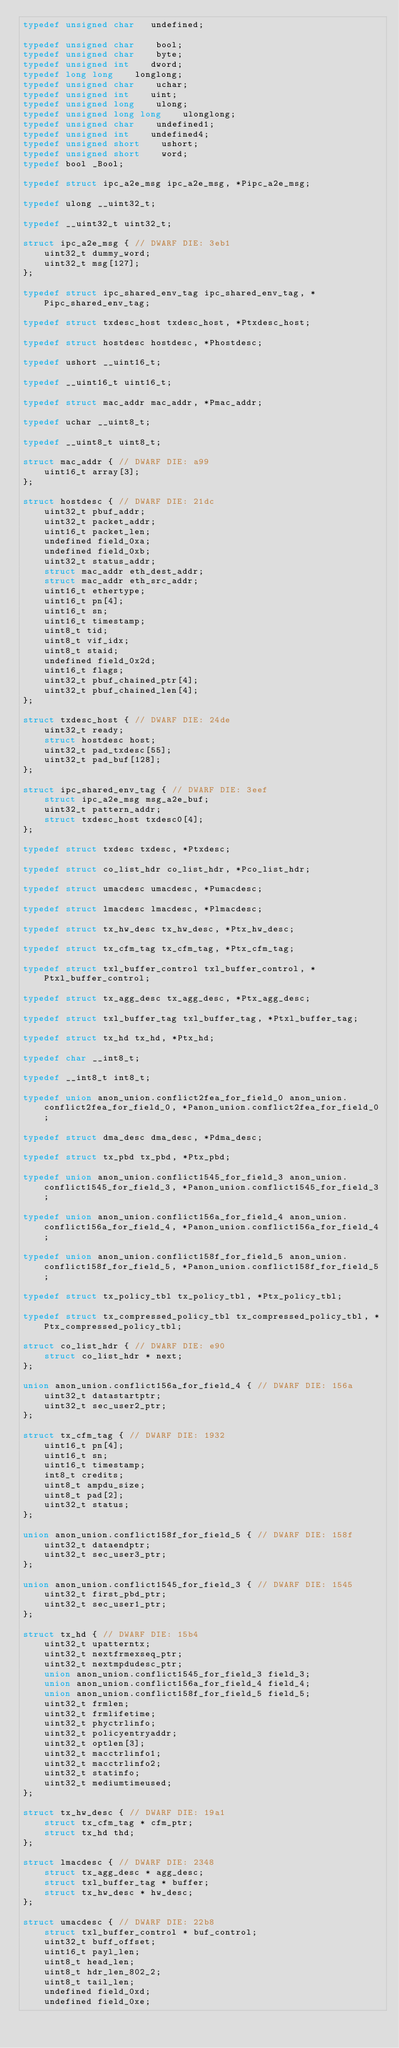Convert code to text. <code><loc_0><loc_0><loc_500><loc_500><_C_>typedef unsigned char   undefined;

typedef unsigned char    bool;
typedef unsigned char    byte;
typedef unsigned int    dword;
typedef long long    longlong;
typedef unsigned char    uchar;
typedef unsigned int    uint;
typedef unsigned long    ulong;
typedef unsigned long long    ulonglong;
typedef unsigned char    undefined1;
typedef unsigned int    undefined4;
typedef unsigned short    ushort;
typedef unsigned short    word;
typedef bool _Bool;

typedef struct ipc_a2e_msg ipc_a2e_msg, *Pipc_a2e_msg;

typedef ulong __uint32_t;

typedef __uint32_t uint32_t;

struct ipc_a2e_msg { // DWARF DIE: 3eb1
    uint32_t dummy_word;
    uint32_t msg[127];
};

typedef struct ipc_shared_env_tag ipc_shared_env_tag, *Pipc_shared_env_tag;

typedef struct txdesc_host txdesc_host, *Ptxdesc_host;

typedef struct hostdesc hostdesc, *Phostdesc;

typedef ushort __uint16_t;

typedef __uint16_t uint16_t;

typedef struct mac_addr mac_addr, *Pmac_addr;

typedef uchar __uint8_t;

typedef __uint8_t uint8_t;

struct mac_addr { // DWARF DIE: a99
    uint16_t array[3];
};

struct hostdesc { // DWARF DIE: 21dc
    uint32_t pbuf_addr;
    uint32_t packet_addr;
    uint16_t packet_len;
    undefined field_0xa;
    undefined field_0xb;
    uint32_t status_addr;
    struct mac_addr eth_dest_addr;
    struct mac_addr eth_src_addr;
    uint16_t ethertype;
    uint16_t pn[4];
    uint16_t sn;
    uint16_t timestamp;
    uint8_t tid;
    uint8_t vif_idx;
    uint8_t staid;
    undefined field_0x2d;
    uint16_t flags;
    uint32_t pbuf_chained_ptr[4];
    uint32_t pbuf_chained_len[4];
};

struct txdesc_host { // DWARF DIE: 24de
    uint32_t ready;
    struct hostdesc host;
    uint32_t pad_txdesc[55];
    uint32_t pad_buf[128];
};

struct ipc_shared_env_tag { // DWARF DIE: 3eef
    struct ipc_a2e_msg msg_a2e_buf;
    uint32_t pattern_addr;
    struct txdesc_host txdesc0[4];
};

typedef struct txdesc txdesc, *Ptxdesc;

typedef struct co_list_hdr co_list_hdr, *Pco_list_hdr;

typedef struct umacdesc umacdesc, *Pumacdesc;

typedef struct lmacdesc lmacdesc, *Plmacdesc;

typedef struct tx_hw_desc tx_hw_desc, *Ptx_hw_desc;

typedef struct tx_cfm_tag tx_cfm_tag, *Ptx_cfm_tag;

typedef struct txl_buffer_control txl_buffer_control, *Ptxl_buffer_control;

typedef struct tx_agg_desc tx_agg_desc, *Ptx_agg_desc;

typedef struct txl_buffer_tag txl_buffer_tag, *Ptxl_buffer_tag;

typedef struct tx_hd tx_hd, *Ptx_hd;

typedef char __int8_t;

typedef __int8_t int8_t;

typedef union anon_union.conflict2fea_for_field_0 anon_union.conflict2fea_for_field_0, *Panon_union.conflict2fea_for_field_0;

typedef struct dma_desc dma_desc, *Pdma_desc;

typedef struct tx_pbd tx_pbd, *Ptx_pbd;

typedef union anon_union.conflict1545_for_field_3 anon_union.conflict1545_for_field_3, *Panon_union.conflict1545_for_field_3;

typedef union anon_union.conflict156a_for_field_4 anon_union.conflict156a_for_field_4, *Panon_union.conflict156a_for_field_4;

typedef union anon_union.conflict158f_for_field_5 anon_union.conflict158f_for_field_5, *Panon_union.conflict158f_for_field_5;

typedef struct tx_policy_tbl tx_policy_tbl, *Ptx_policy_tbl;

typedef struct tx_compressed_policy_tbl tx_compressed_policy_tbl, *Ptx_compressed_policy_tbl;

struct co_list_hdr { // DWARF DIE: e90
    struct co_list_hdr * next;
};

union anon_union.conflict156a_for_field_4 { // DWARF DIE: 156a
    uint32_t datastartptr;
    uint32_t sec_user2_ptr;
};

struct tx_cfm_tag { // DWARF DIE: 1932
    uint16_t pn[4];
    uint16_t sn;
    uint16_t timestamp;
    int8_t credits;
    uint8_t ampdu_size;
    uint8_t pad[2];
    uint32_t status;
};

union anon_union.conflict158f_for_field_5 { // DWARF DIE: 158f
    uint32_t dataendptr;
    uint32_t sec_user3_ptr;
};

union anon_union.conflict1545_for_field_3 { // DWARF DIE: 1545
    uint32_t first_pbd_ptr;
    uint32_t sec_user1_ptr;
};

struct tx_hd { // DWARF DIE: 15b4
    uint32_t upatterntx;
    uint32_t nextfrmexseq_ptr;
    uint32_t nextmpdudesc_ptr;
    union anon_union.conflict1545_for_field_3 field_3;
    union anon_union.conflict156a_for_field_4 field_4;
    union anon_union.conflict158f_for_field_5 field_5;
    uint32_t frmlen;
    uint32_t frmlifetime;
    uint32_t phyctrlinfo;
    uint32_t policyentryaddr;
    uint32_t optlen[3];
    uint32_t macctrlinfo1;
    uint32_t macctrlinfo2;
    uint32_t statinfo;
    uint32_t mediumtimeused;
};

struct tx_hw_desc { // DWARF DIE: 19a1
    struct tx_cfm_tag * cfm_ptr;
    struct tx_hd thd;
};

struct lmacdesc { // DWARF DIE: 2348
    struct tx_agg_desc * agg_desc;
    struct txl_buffer_tag * buffer;
    struct tx_hw_desc * hw_desc;
};

struct umacdesc { // DWARF DIE: 22b8
    struct txl_buffer_control * buf_control;
    uint32_t buff_offset;
    uint16_t payl_len;
    uint8_t head_len;
    uint8_t hdr_len_802_2;
    uint8_t tail_len;
    undefined field_0xd;
    undefined field_0xe;</code> 